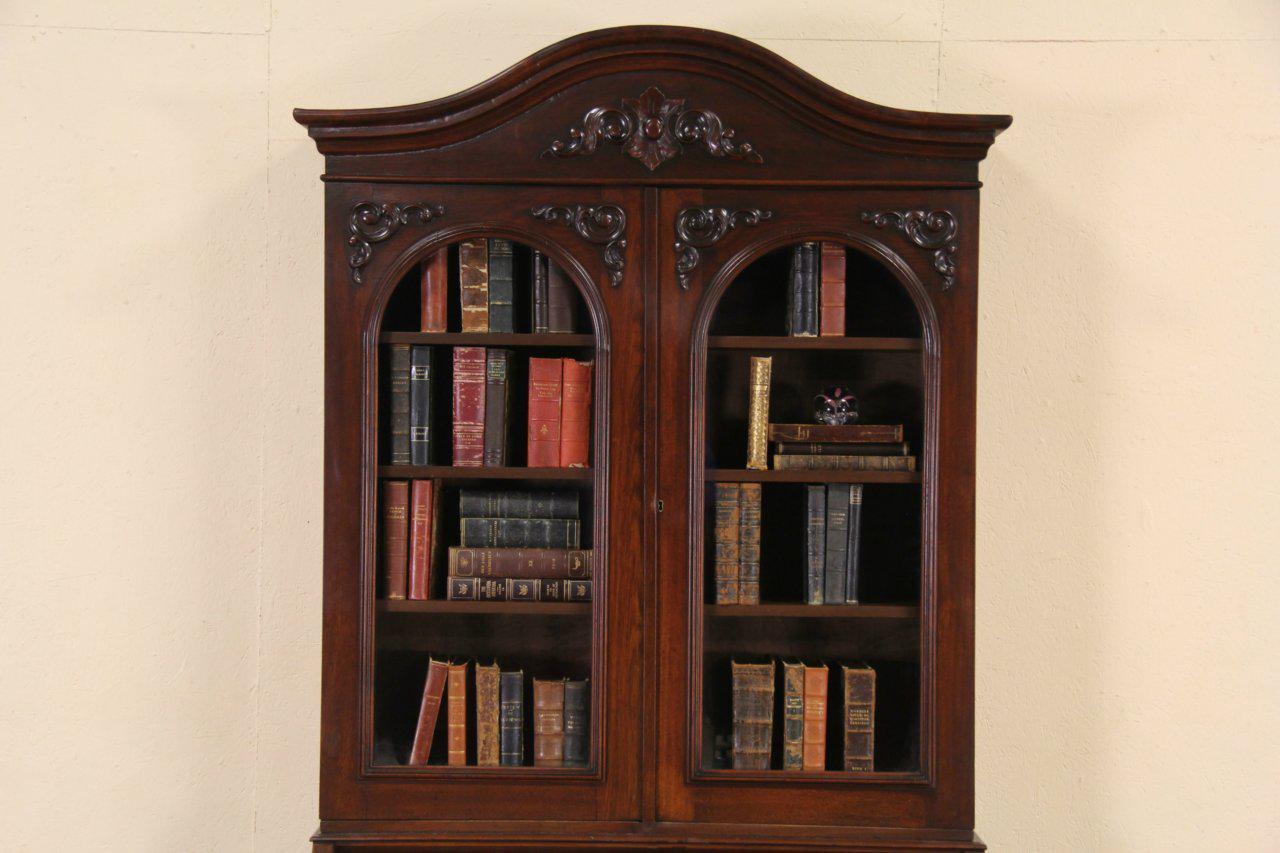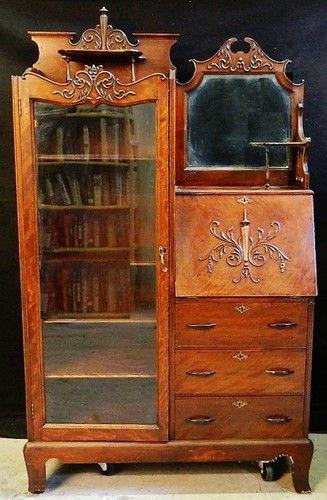The first image is the image on the left, the second image is the image on the right. Evaluate the accuracy of this statement regarding the images: "there is a cabinet with a glass door n the left and a mirror and 3 drawers on the right". Is it true? Answer yes or no. Yes. The first image is the image on the left, the second image is the image on the right. Considering the images on both sides, is "The hutch has side by side doors with window panels." valid? Answer yes or no. Yes. 